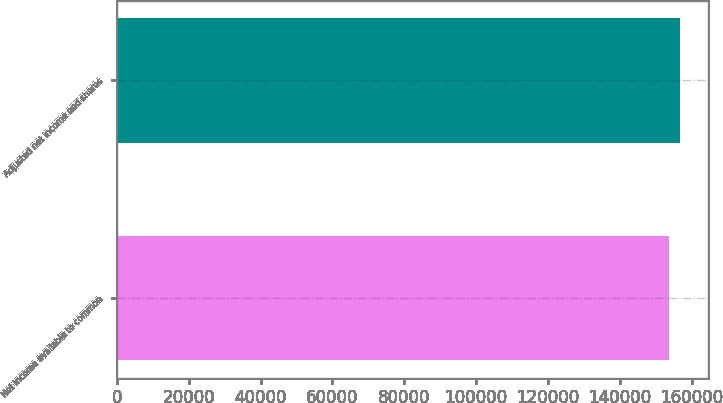<chart> <loc_0><loc_0><loc_500><loc_500><bar_chart><fcel>Net income available to common<fcel>Adjusted net income and shares<nl><fcel>153773<fcel>156759<nl></chart> 